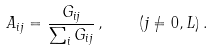<formula> <loc_0><loc_0><loc_500><loc_500>A _ { i j } = \frac { G _ { i j } } { \sum _ { i } G _ { i j } } \, , \quad ( j \neq 0 , L ) \, .</formula> 